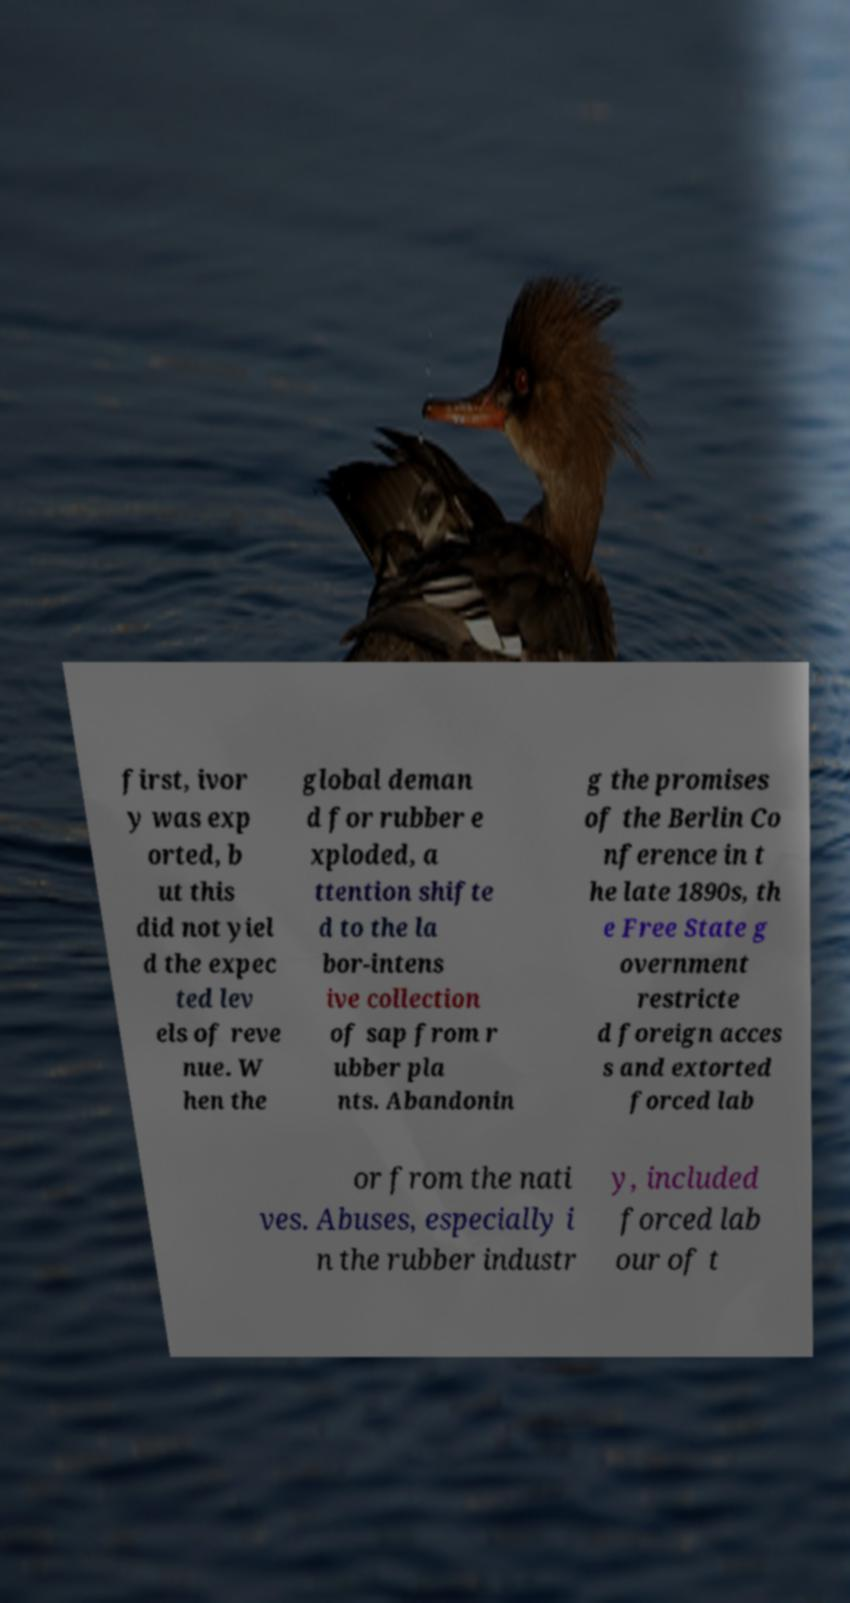For documentation purposes, I need the text within this image transcribed. Could you provide that? first, ivor y was exp orted, b ut this did not yiel d the expec ted lev els of reve nue. W hen the global deman d for rubber e xploded, a ttention shifte d to the la bor-intens ive collection of sap from r ubber pla nts. Abandonin g the promises of the Berlin Co nference in t he late 1890s, th e Free State g overnment restricte d foreign acces s and extorted forced lab or from the nati ves. Abuses, especially i n the rubber industr y, included forced lab our of t 